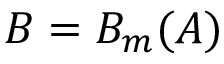<formula> <loc_0><loc_0><loc_500><loc_500>B = B _ { m } ( A )</formula> 